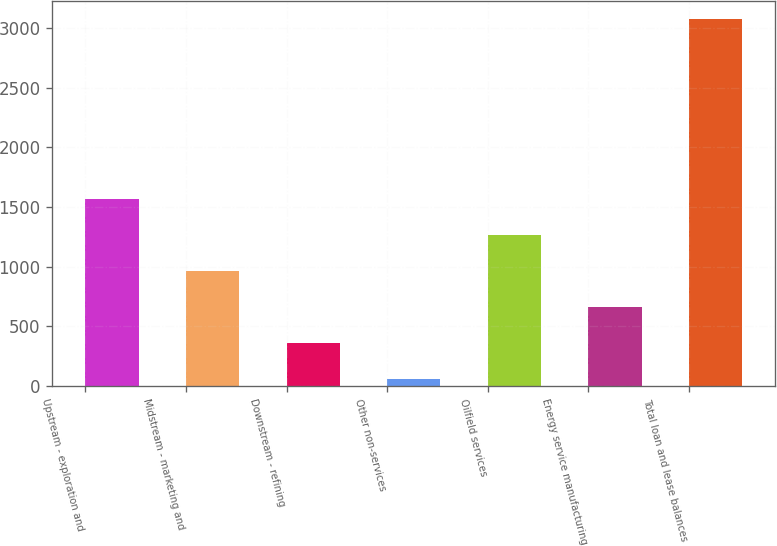Convert chart to OTSL. <chart><loc_0><loc_0><loc_500><loc_500><bar_chart><fcel>Upstream - exploration and<fcel>Midstream - marketing and<fcel>Downstream - refining<fcel>Other non-services<fcel>Oilfield services<fcel>Energy service manufacturing<fcel>Total loan and lease balances<nl><fcel>1564<fcel>960.4<fcel>356.8<fcel>55<fcel>1262.2<fcel>658.6<fcel>3073<nl></chart> 